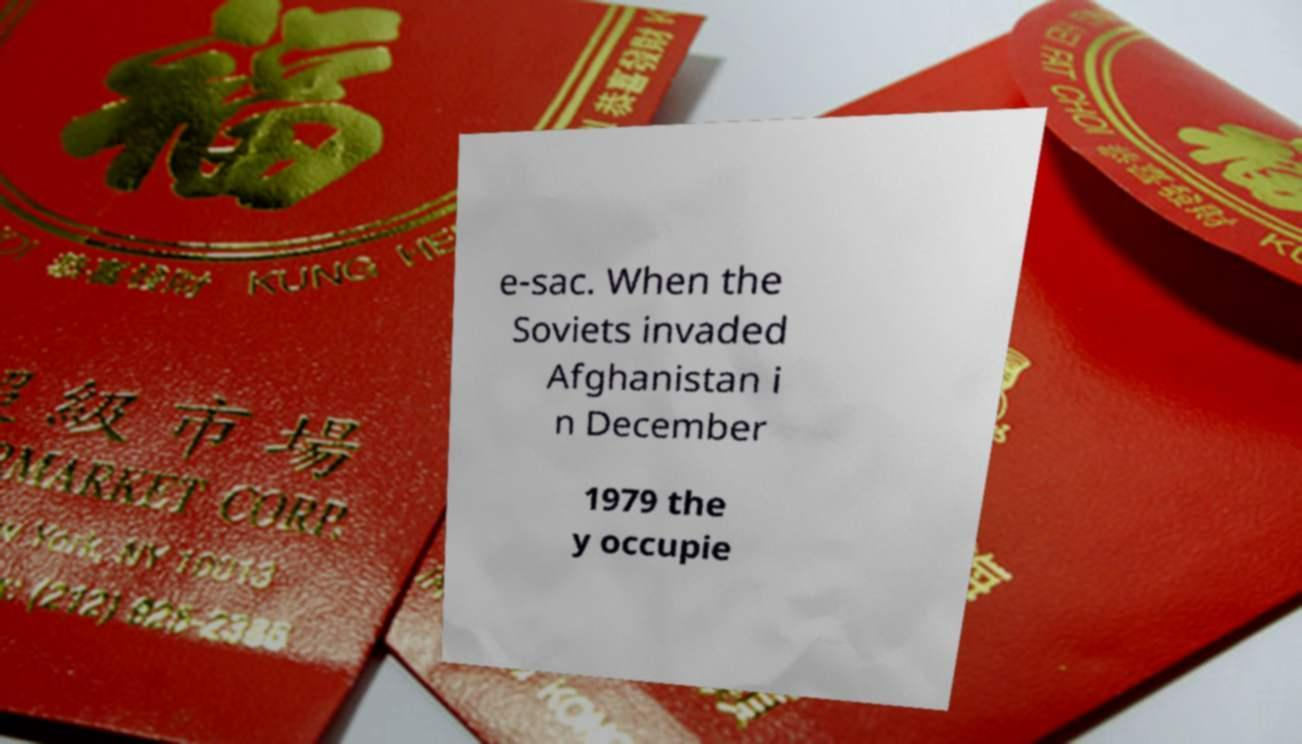Could you extract and type out the text from this image? e-sac. When the Soviets invaded Afghanistan i n December 1979 the y occupie 